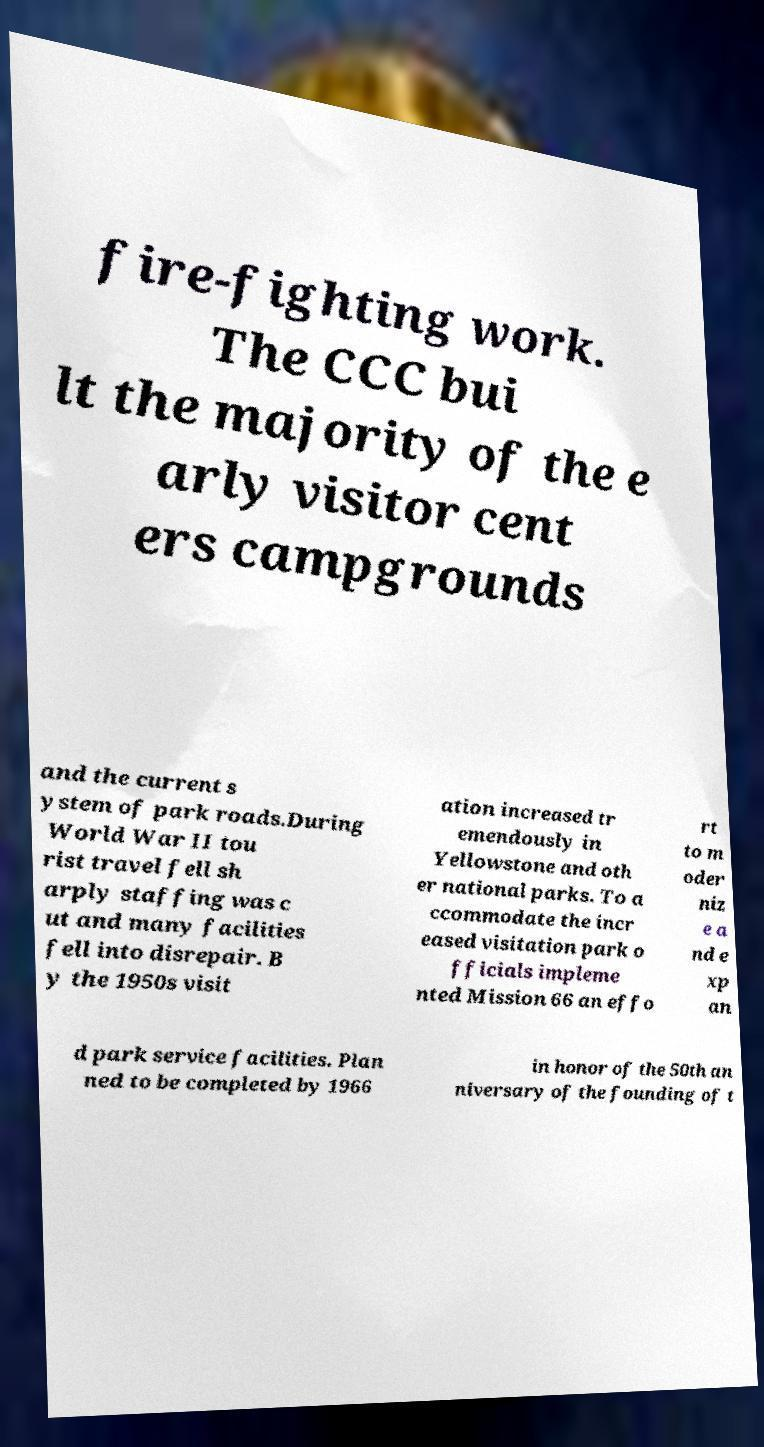Please read and relay the text visible in this image. What does it say? fire-fighting work. The CCC bui lt the majority of the e arly visitor cent ers campgrounds and the current s ystem of park roads.During World War II tou rist travel fell sh arply staffing was c ut and many facilities fell into disrepair. B y the 1950s visit ation increased tr emendously in Yellowstone and oth er national parks. To a ccommodate the incr eased visitation park o fficials impleme nted Mission 66 an effo rt to m oder niz e a nd e xp an d park service facilities. Plan ned to be completed by 1966 in honor of the 50th an niversary of the founding of t 